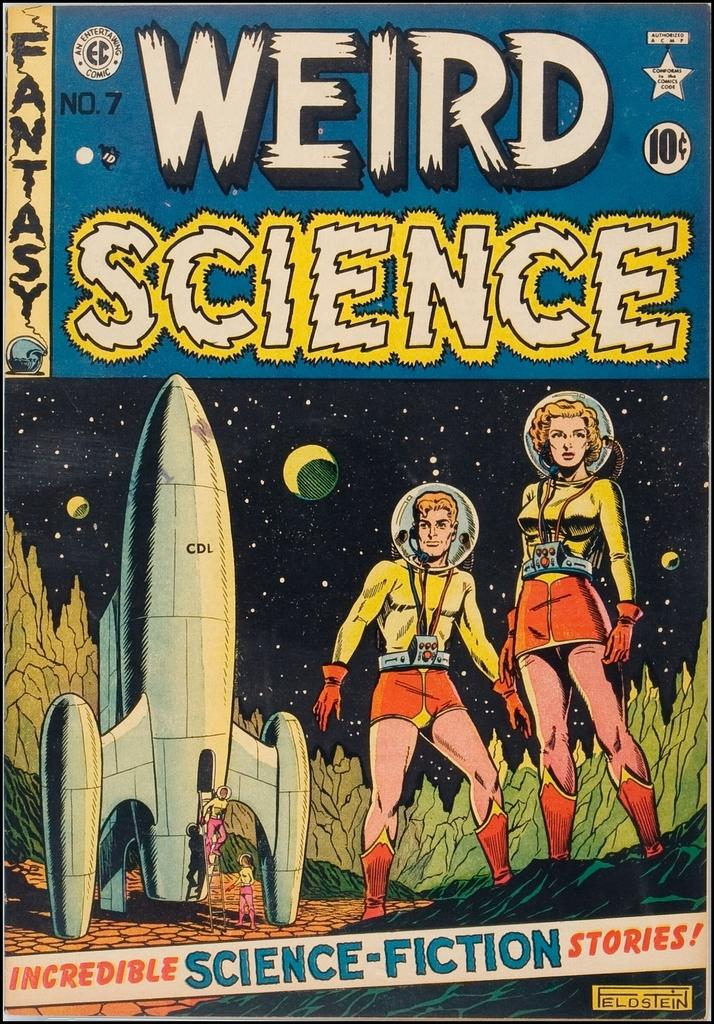<image>
Write a terse but informative summary of the picture. Volume number seven of the Weird Science comic book series. 